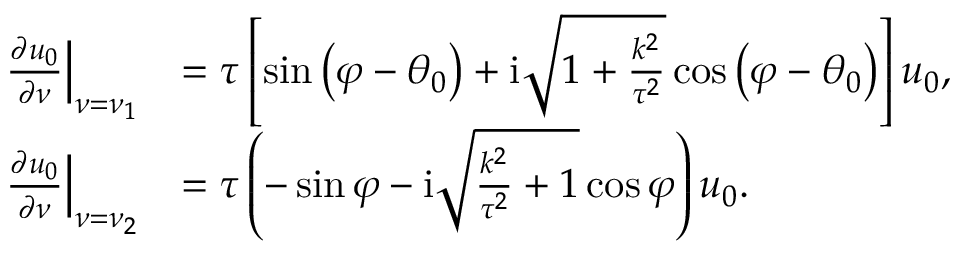Convert formula to latex. <formula><loc_0><loc_0><loc_500><loc_500>\begin{array} { r l } { \frac { \partial u _ { 0 } } { \partial \nu } \left | _ { \nu = \nu _ { 1 } } } & { = \tau \left [ \sin \left ( \varphi - \theta _ { 0 } \right ) + i \sqrt { 1 + \frac { k ^ { 2 } } { \tau ^ { 2 } } } \cos \left ( \varphi - \theta _ { 0 } \right ) \right ] u _ { 0 } , } \\ { \frac { \partial u _ { 0 } } { \partial \nu } \right | _ { \nu = \nu _ { 2 } } } & { = \tau \left ( - \sin \varphi - \mathrm i \sqrt { \frac { k ^ { 2 } } { \tau ^ { 2 } } + 1 } \cos \varphi \right ) u _ { 0 } . } \end{array}</formula> 